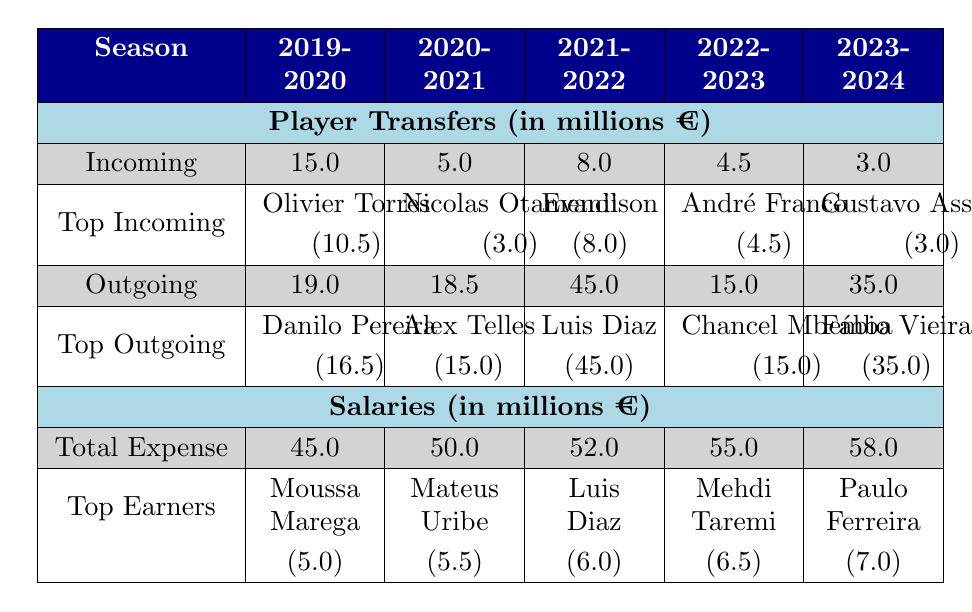What was the total incoming transfer amount for FC Porto in the 2021-2022 season? The table shows that the Total Incoming Transfers for the 2021-2022 season is 8.0 million euros.
Answer: 8.0 Which player had the highest outgoing transfer fee in the 2020-2021 season? According to the table, the player with the highest outgoing transfer fee in the 2020-2021 season is Alex Telles, with a transfer fee of 15.0 million euros.
Answer: Alex Telles What is the total outgoing transfer amount for FC Porto over the last five seasons? To find the total outgoing transfer amount, we sum the outgoing transfers for each season: 19.0 + 18.5 + 45.0 + 15.0 + 35.0 = 132.5 million euros.
Answer: 132.5 Did FC Porto's total salary expense increase every season from 2019-2020 to 2023-2024? By examining the total salary expenses for each season: 45.0, 50.0, 52.0, 55.0, and 58.0 million euros, we see that it has indeed increased each year.
Answer: Yes What was the average outgoing transfer fee per season for FC Porto over the last five seasons? The outgoing transfer amounts are 19.0, 18.5, 45.0, 15.0, and 35.0 million euros. The sum is 132.5 million euros, and there are 5 seasons, so the average is 132.5 / 5 = 26.5 million euros.
Answer: 26.5 Which player was the top earner for FC Porto in the 2022-2023 season? The table indicates that the top earner in the 2022-2023 season was Mehdi Taremi with an annual salary of 6.5 million euros.
Answer: Mehdi Taremi If we compare the total incoming transfers from the 2019-2020 season to the 2023-2024 season, did it increase or decrease? The Total Incoming Transfers for 2019-2020 is 15.0 million euros, whereas for 2023-2024 it is 3.0 million euros. Therefore, there was a decrease in incoming transfers.
Answer: Decrease What is the difference in total salary expense between the 2020-2021 and 2021-2022 seasons? The total salary expense in the 2020-2021 season is 50.0 million euros, and in the 2021-2022 season it is 52.0 million euros. The difference is 52.0 - 50.0 = 2.0 million euros.
Answer: 2.0 What percentage of the total salary expense in the 2023-2024 season does the annual salary of the top earner represent? In the 2023-2024 season, the total salary expense is 58.0 million euros, and the top earner's salary is 7.0 million euros. The percentage is (7.0 / 58.0) * 100 = 12.07%.
Answer: 12.07% 